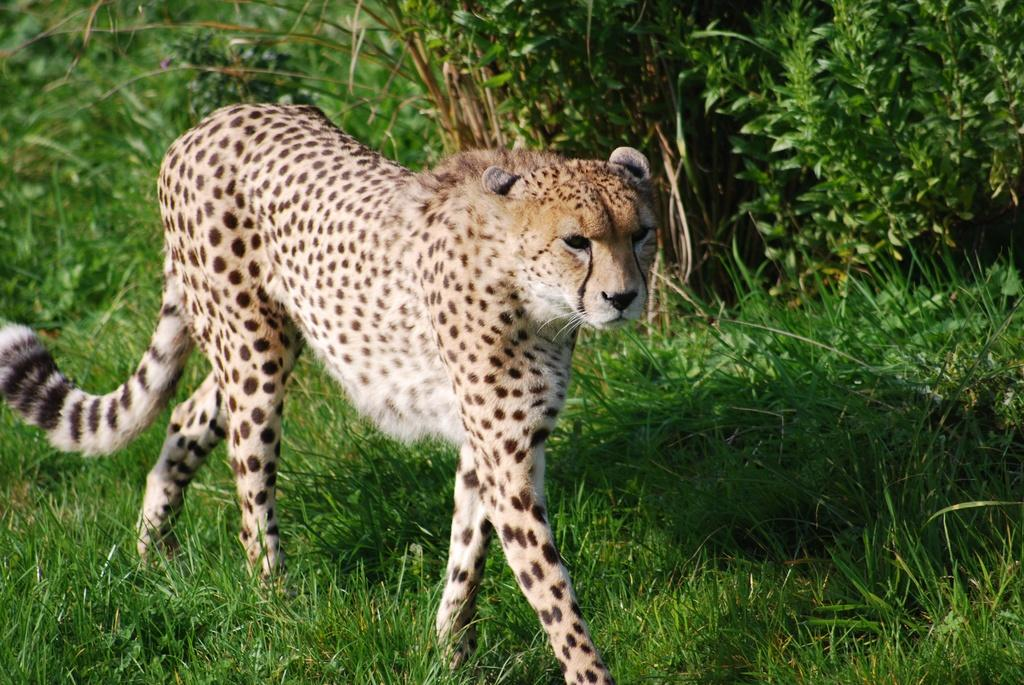What animal is in the image? There is a cheetah in the image. What is the cheetah doing in the image? The cheetah is walking on the ground. What type of terrain is the cheetah walking on? There is grass on the ground. What can be seen in the background of the image? There are plants behind the cheetah. What type of net is being used by the cheetah in the image? There is no net present in the image; the cheetah is simply walking on the grass. 